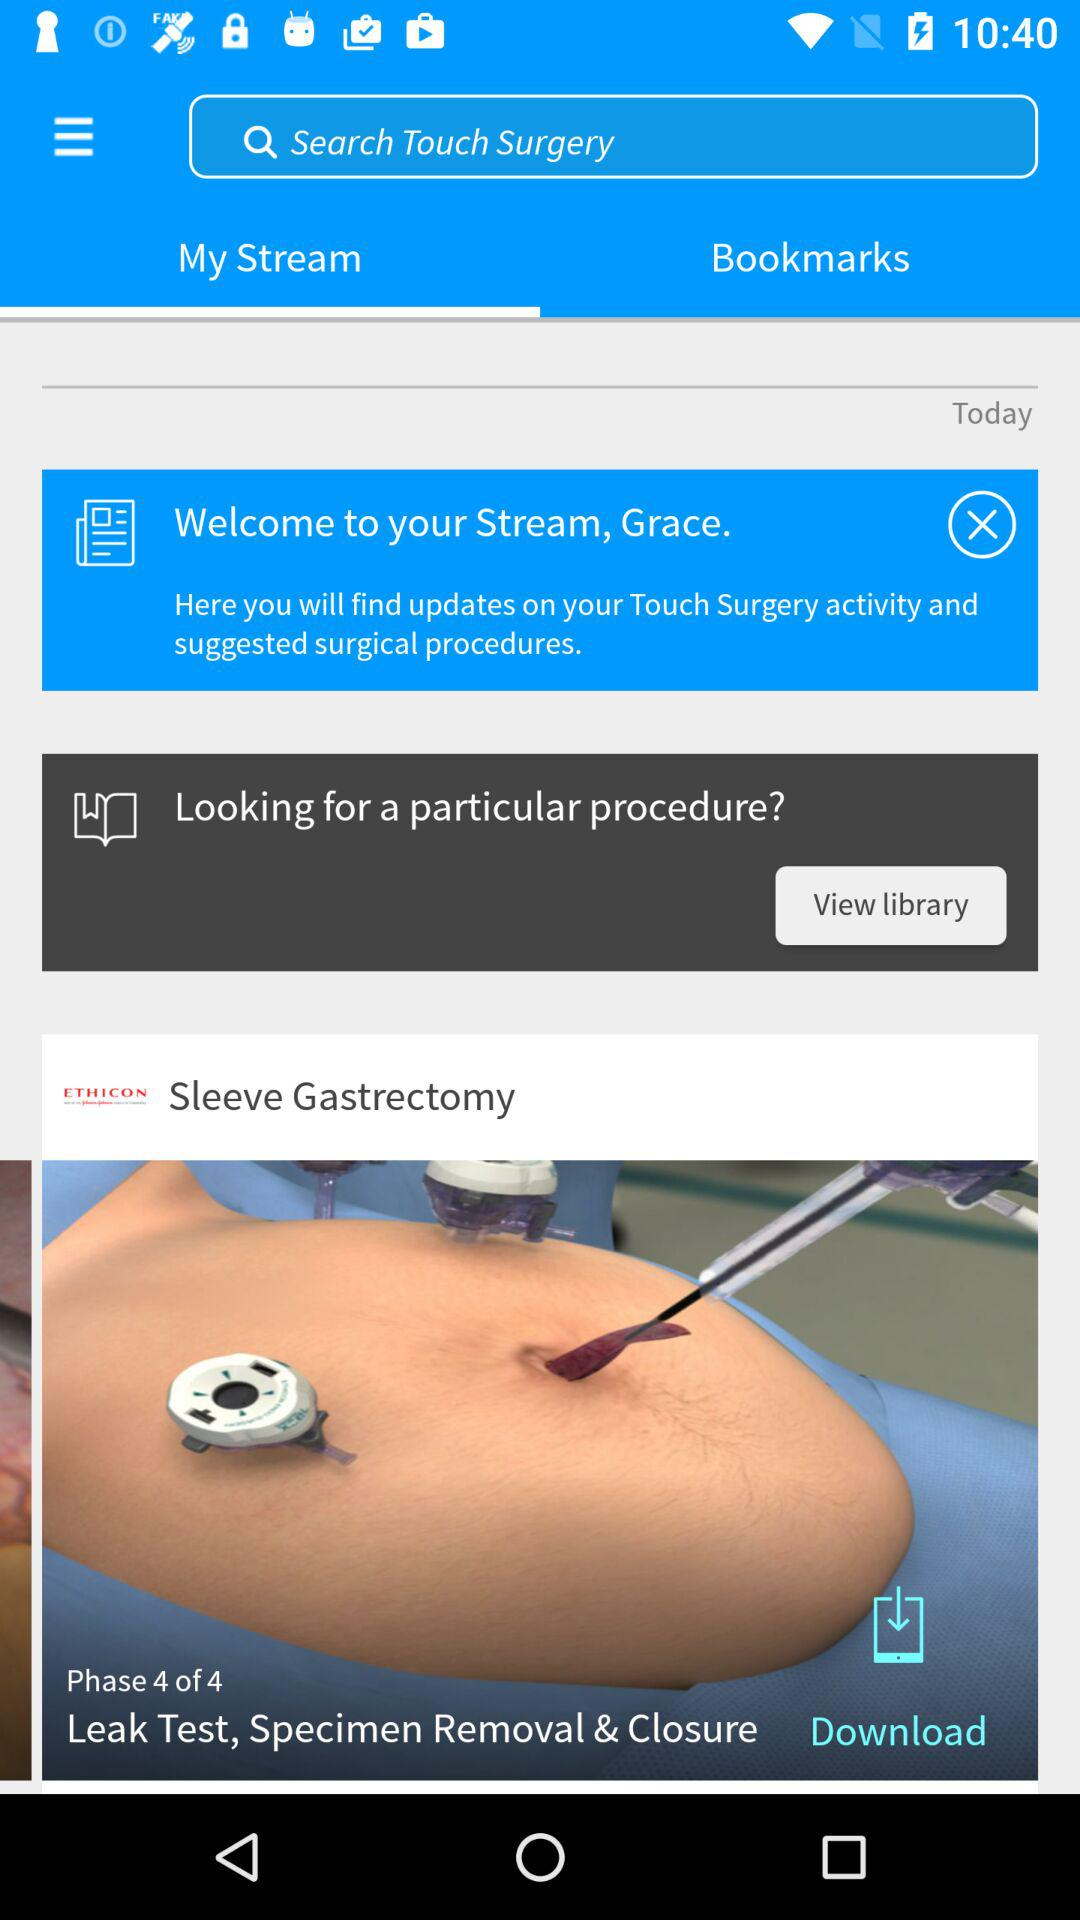Which tab is selected? The selected tab is "My Stream". 